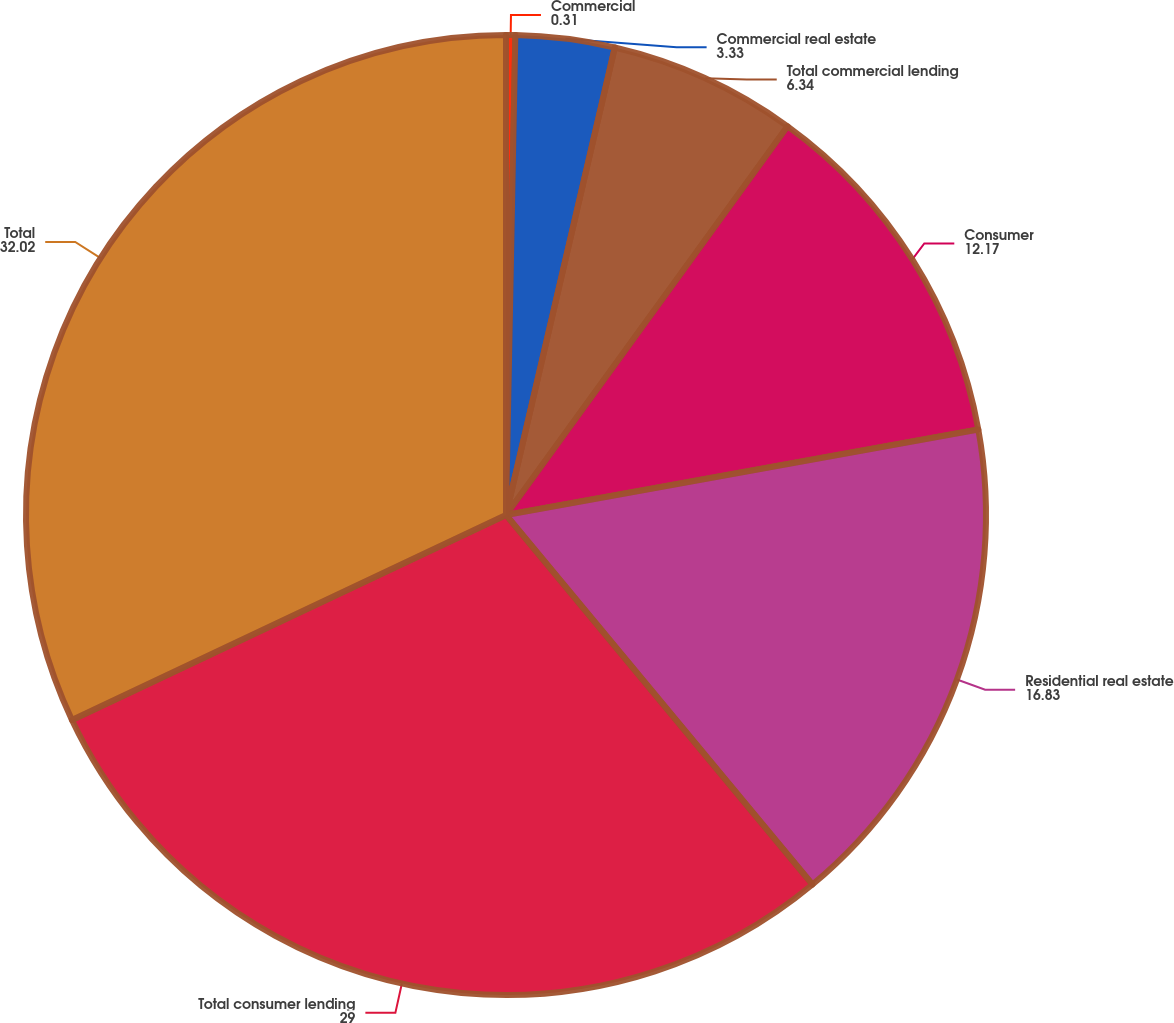<chart> <loc_0><loc_0><loc_500><loc_500><pie_chart><fcel>Commercial<fcel>Commercial real estate<fcel>Total commercial lending<fcel>Consumer<fcel>Residential real estate<fcel>Total consumer lending<fcel>Total<nl><fcel>0.31%<fcel>3.33%<fcel>6.34%<fcel>12.17%<fcel>16.83%<fcel>29.0%<fcel>32.02%<nl></chart> 